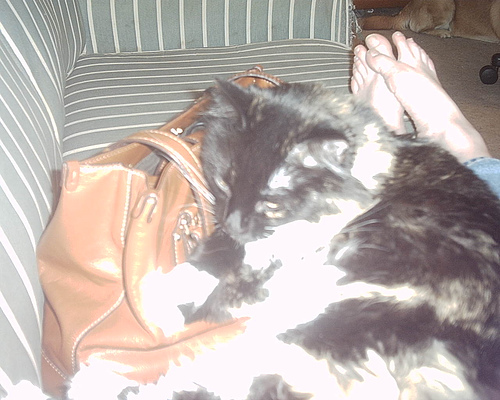Describe the surroundings where the cat is resting. The cat is lying on a couch with green and white stripes. Next to the cat, there is a brown handbag. In the background, you can see someone's feet, suggesting they are sitting on the couch, and there are some objects on the floor which might include another pet. 